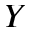Convert formula to latex. <formula><loc_0><loc_0><loc_500><loc_500>Y</formula> 